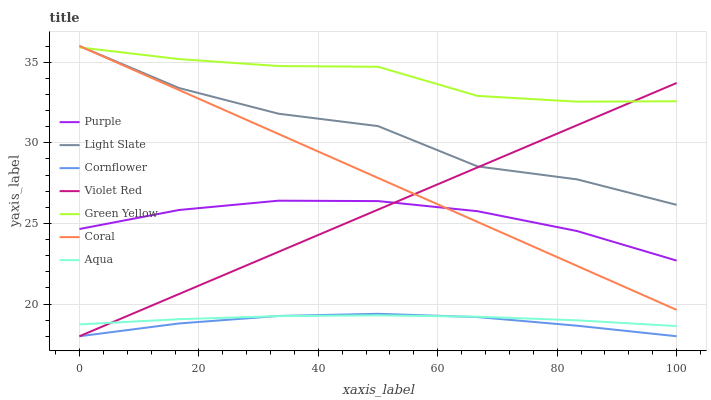Does Cornflower have the minimum area under the curve?
Answer yes or no. Yes. Does Green Yellow have the maximum area under the curve?
Answer yes or no. Yes. Does Violet Red have the minimum area under the curve?
Answer yes or no. No. Does Violet Red have the maximum area under the curve?
Answer yes or no. No. Is Coral the smoothest?
Answer yes or no. Yes. Is Light Slate the roughest?
Answer yes or no. Yes. Is Violet Red the smoothest?
Answer yes or no. No. Is Violet Red the roughest?
Answer yes or no. No. Does Purple have the lowest value?
Answer yes or no. No. Does Violet Red have the highest value?
Answer yes or no. No. Is Aqua less than Light Slate?
Answer yes or no. Yes. Is Purple greater than Cornflower?
Answer yes or no. Yes. Does Aqua intersect Light Slate?
Answer yes or no. No. 